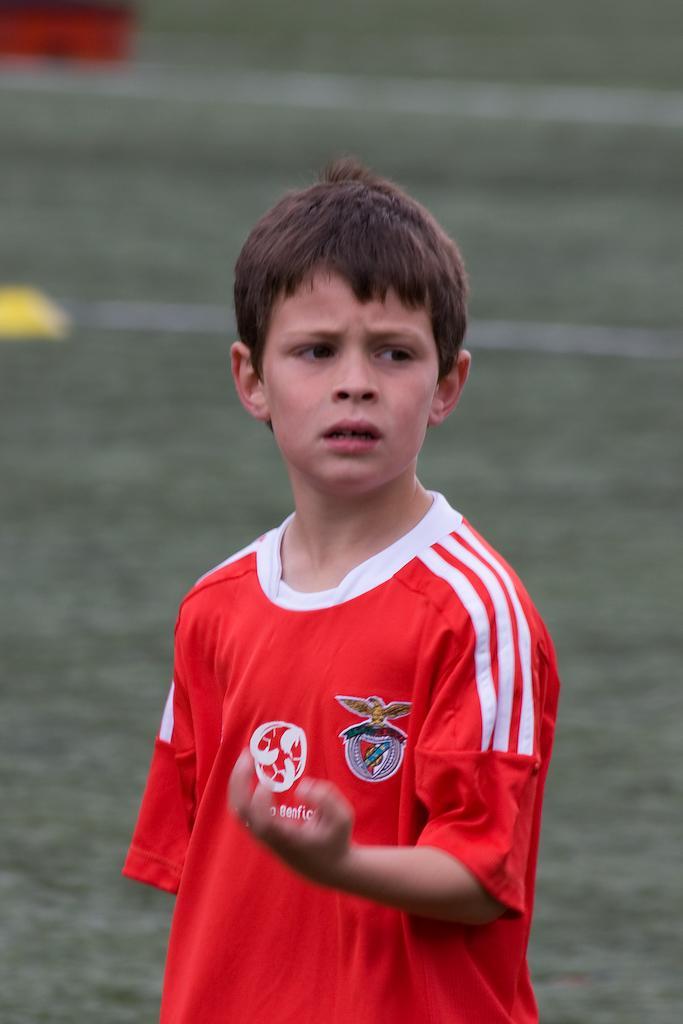Could you give a brief overview of what you see in this image? In this image I can see a boy is standing. The boy is wearing a red color t-shirt. The background of the image is blurred. 